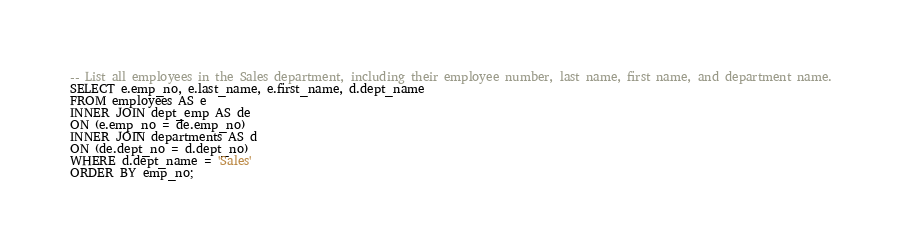Convert code to text. <code><loc_0><loc_0><loc_500><loc_500><_SQL_>-- List all employees in the Sales department, including their employee number, last name, first name, and department name.
SELECT e.emp_no, e.last_name, e.first_name, d.dept_name
FROM employees AS e
INNER JOIN dept_emp AS de
ON (e.emp_no = de.emp_no)
INNER JOIN departments AS d
ON (de.dept_no = d.dept_no)
WHERE d.dept_name = 'Sales'
ORDER BY emp_no;</code> 